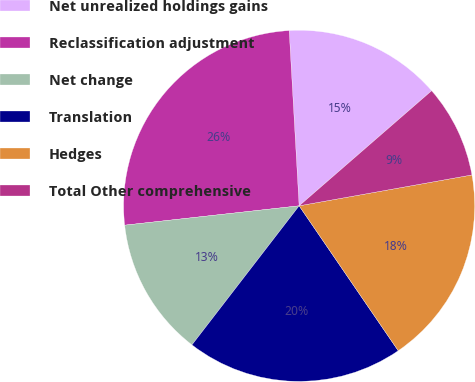Convert chart. <chart><loc_0><loc_0><loc_500><loc_500><pie_chart><fcel>Net unrealized holdings gains<fcel>Reclassification adjustment<fcel>Net change<fcel>Translation<fcel>Hedges<fcel>Total Other comprehensive<nl><fcel>14.52%<fcel>25.86%<fcel>12.79%<fcel>20.0%<fcel>18.27%<fcel>8.57%<nl></chart> 